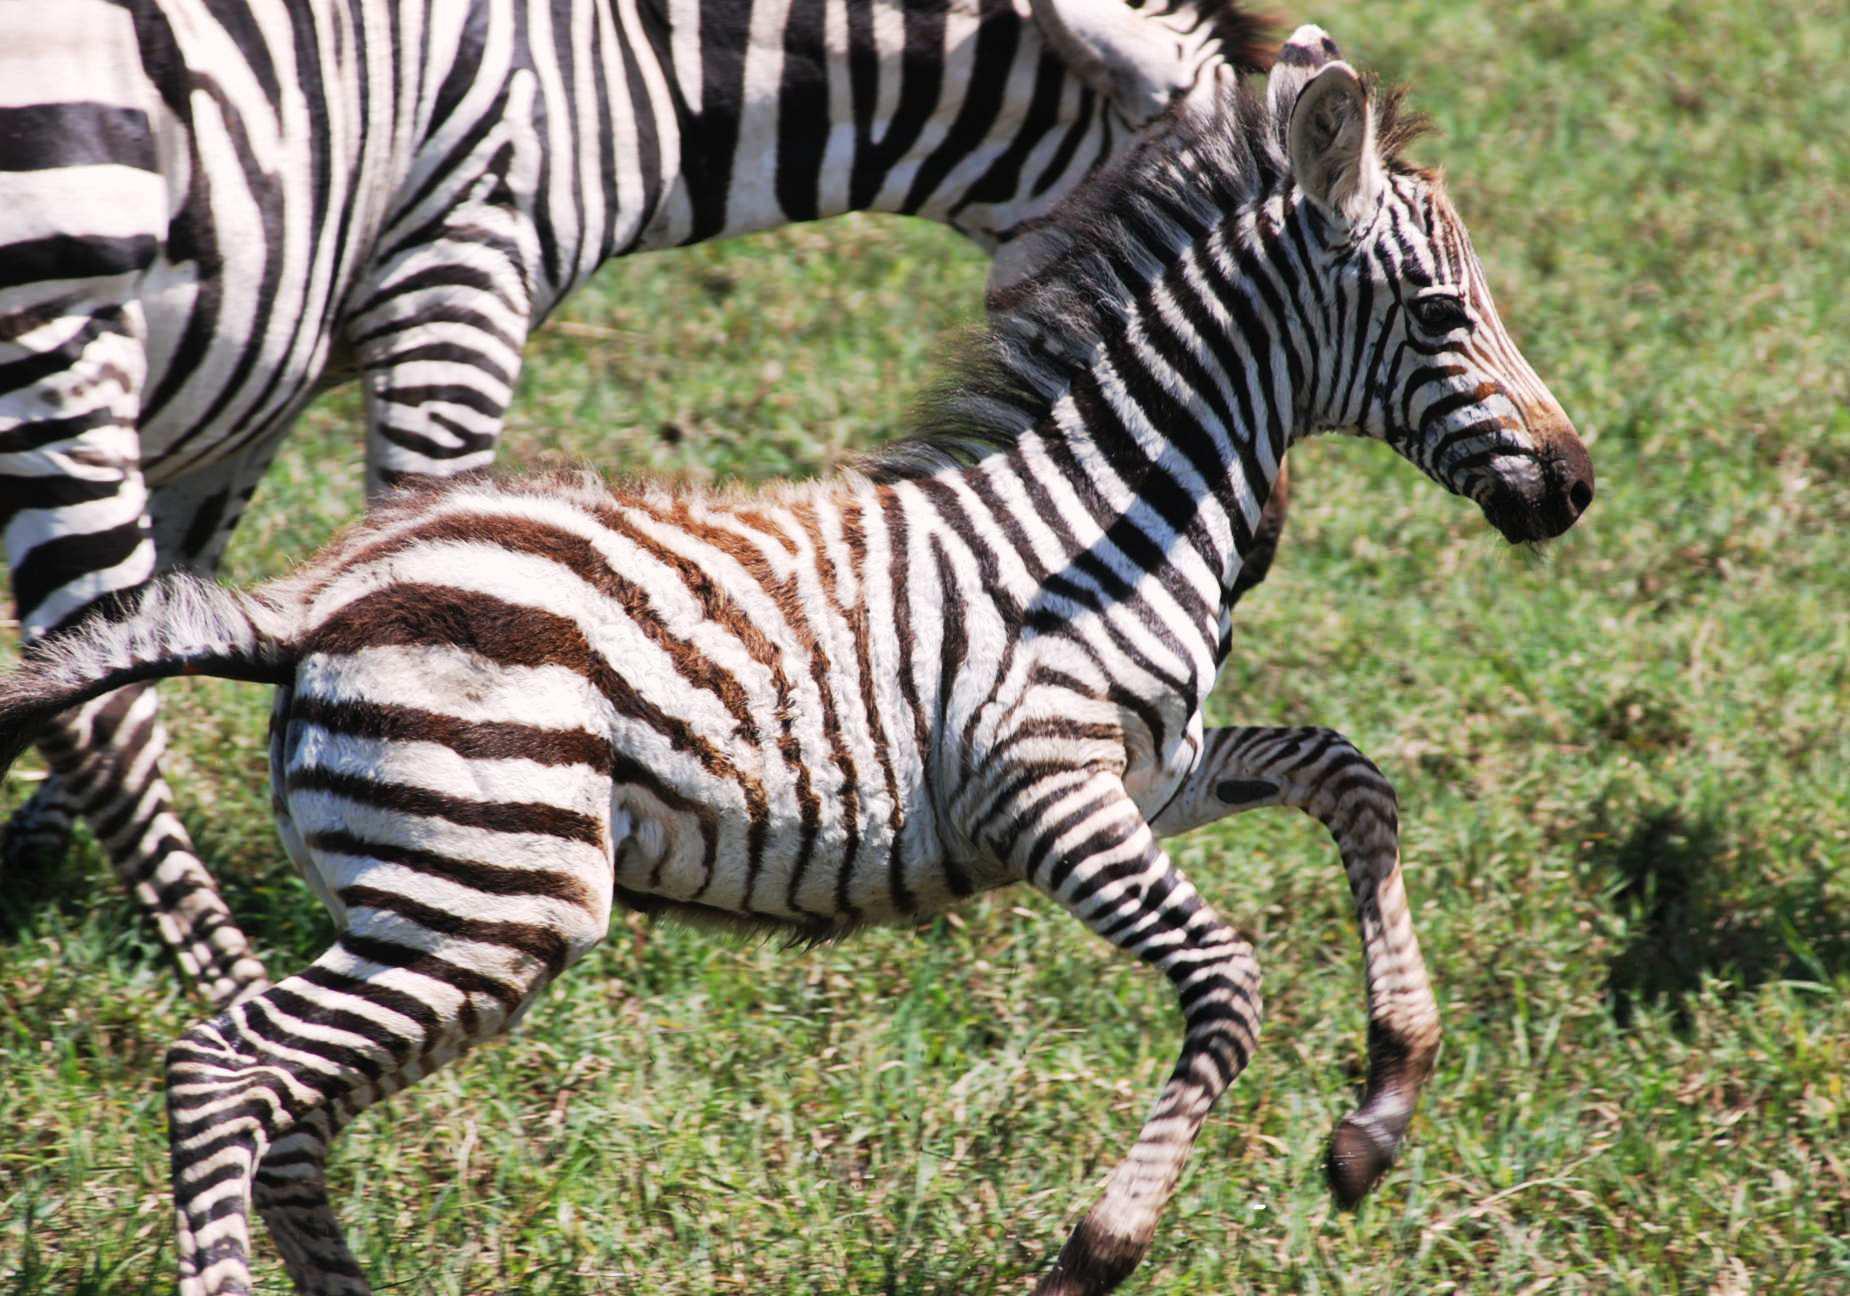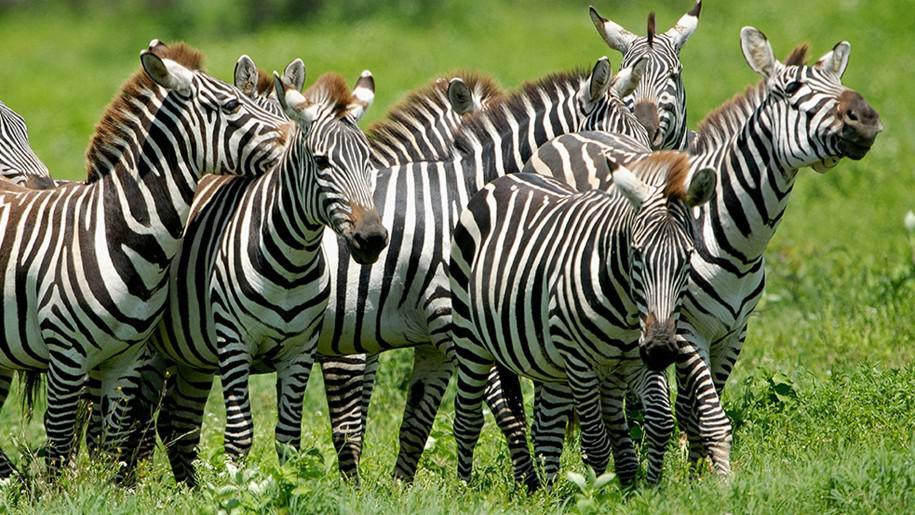The first image is the image on the left, the second image is the image on the right. For the images displayed, is the sentence "There is more than one species of animal present." factually correct? Answer yes or no. No. The first image is the image on the left, the second image is the image on the right. Evaluate the accuracy of this statement regarding the images: "A taller standing zebra is left of a smaller standing zebra in one image, and the other image shows a zebra standing with its body turned rightward.". Is it true? Answer yes or no. No. 